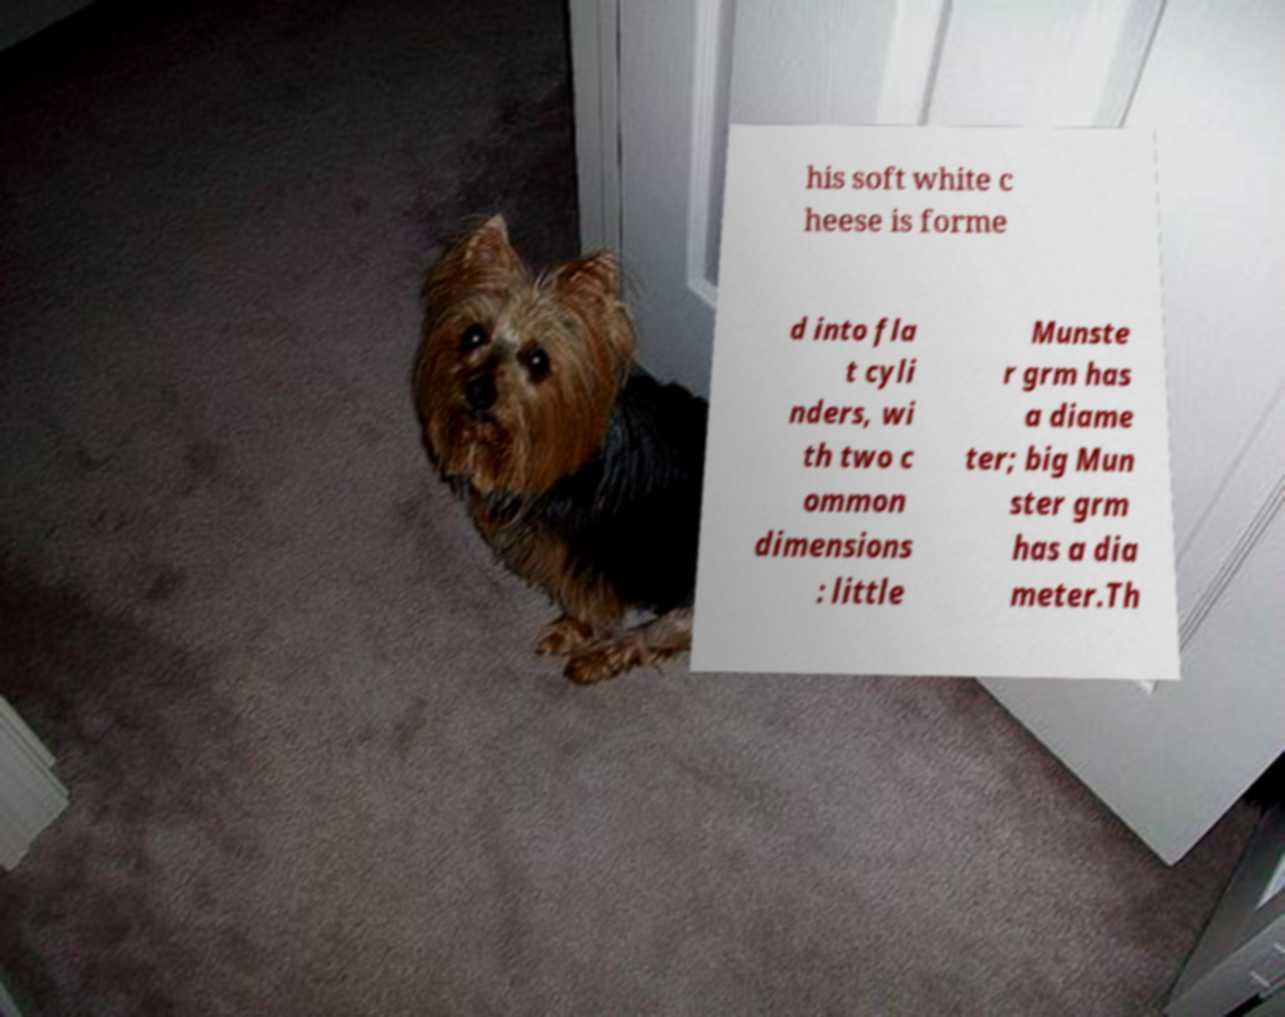What messages or text are displayed in this image? I need them in a readable, typed format. his soft white c heese is forme d into fla t cyli nders, wi th two c ommon dimensions : little Munste r grm has a diame ter; big Mun ster grm has a dia meter.Th 